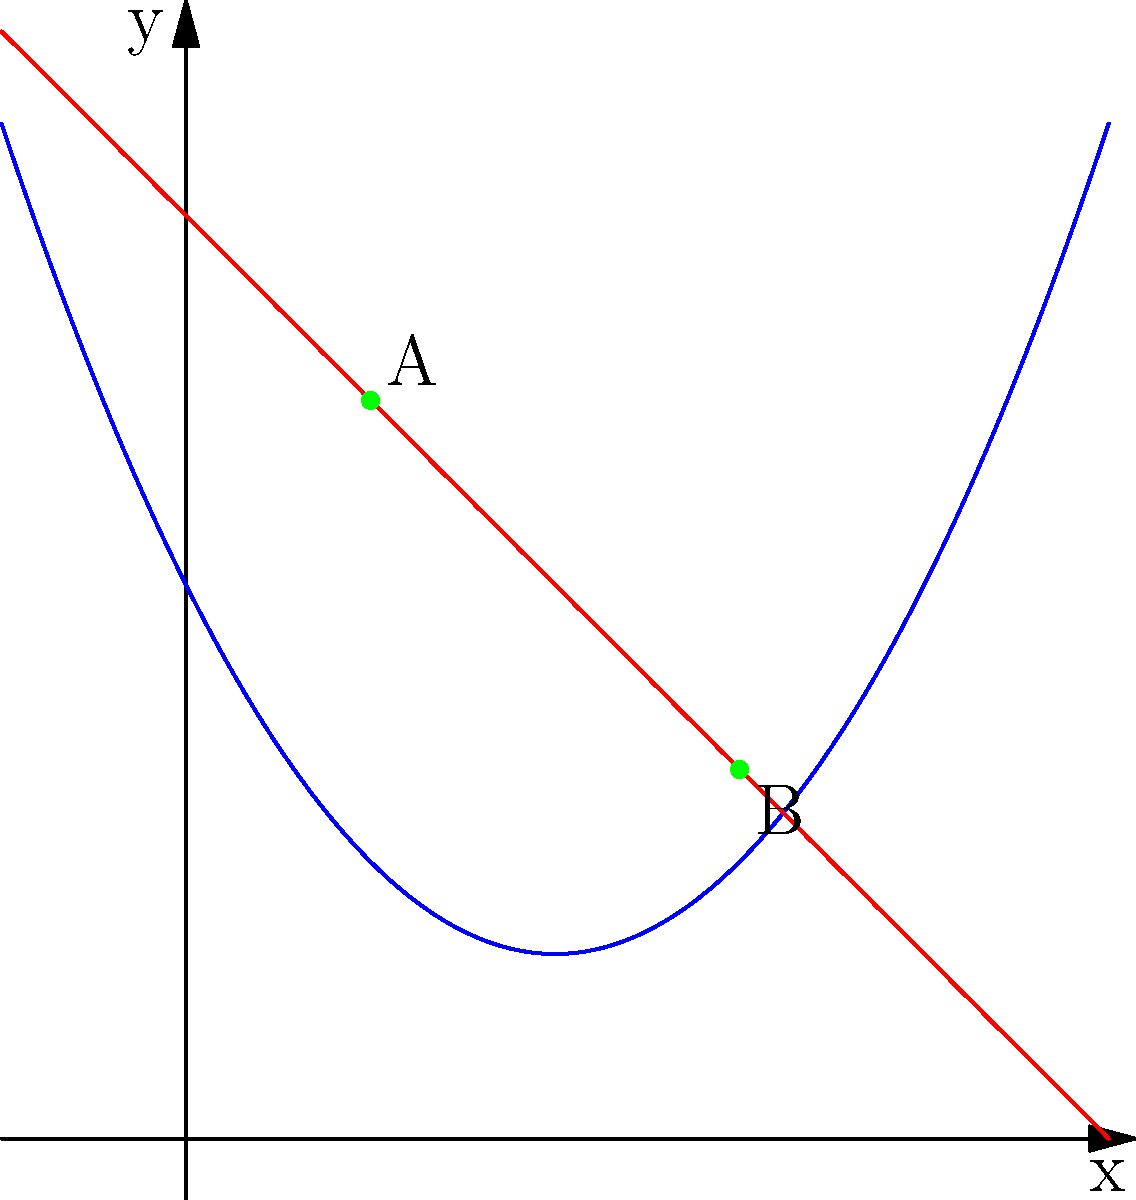In a consumer behavior study, a parabolic curve represents consumer preferences for a product, while a straight line represents the budget constraint. The parabola is given by the equation $y = 0.5x^2 - 2x + 3$, and the budget line is represented by $y = -x + 5$. At which points do these curves intersect, and what do these intersection points signify in terms of consumer behavior? To find the intersection points, we need to solve the equation:

$$0.5x^2 - 2x + 3 = -x + 5$$

Step 1: Rearrange the equation
$$0.5x^2 - x - 2 = 0$$

Step 2: Use the quadratic formula $x = \frac{-b \pm \sqrt{b^2 - 4ac}}{2a}$
Where $a = 0.5$, $b = -1$, and $c = -2$

$$x = \frac{1 \pm \sqrt{1 - 4(0.5)(-2)}}{2(0.5)}$$
$$x = \frac{1 \pm \sqrt{5}}{1}$$

Step 3: Solve for x
$$x_1 = 1 + \sqrt{5} \approx 3$$
$$x_2 = 1 - \sqrt{5} \approx 1$$

Step 4: Find the corresponding y-values
For $x_1 = 3$: $y_1 = -3 + 5 = 2$
For $x_2 = 1$: $y_2 = -1 + 5 = 4$

The intersection points are approximately (3, 2) and (1, 4).

In terms of consumer behavior:
1. Point A (1, 4): This represents a consumer choice with lower quantity but higher perceived value.
2. Point B (3, 2): This represents a consumer choice with higher quantity but lower perceived value.

Both points are optimal choices as they satisfy both the consumer's preference (on the parabola) and budget constraint (on the line). The consumer would be indifferent between these two choices, as they both maximize utility within the given budget.
Answer: (3, 2) and (1, 4); representing optimal consumer choices balancing quantity and perceived value within budget constraints. 